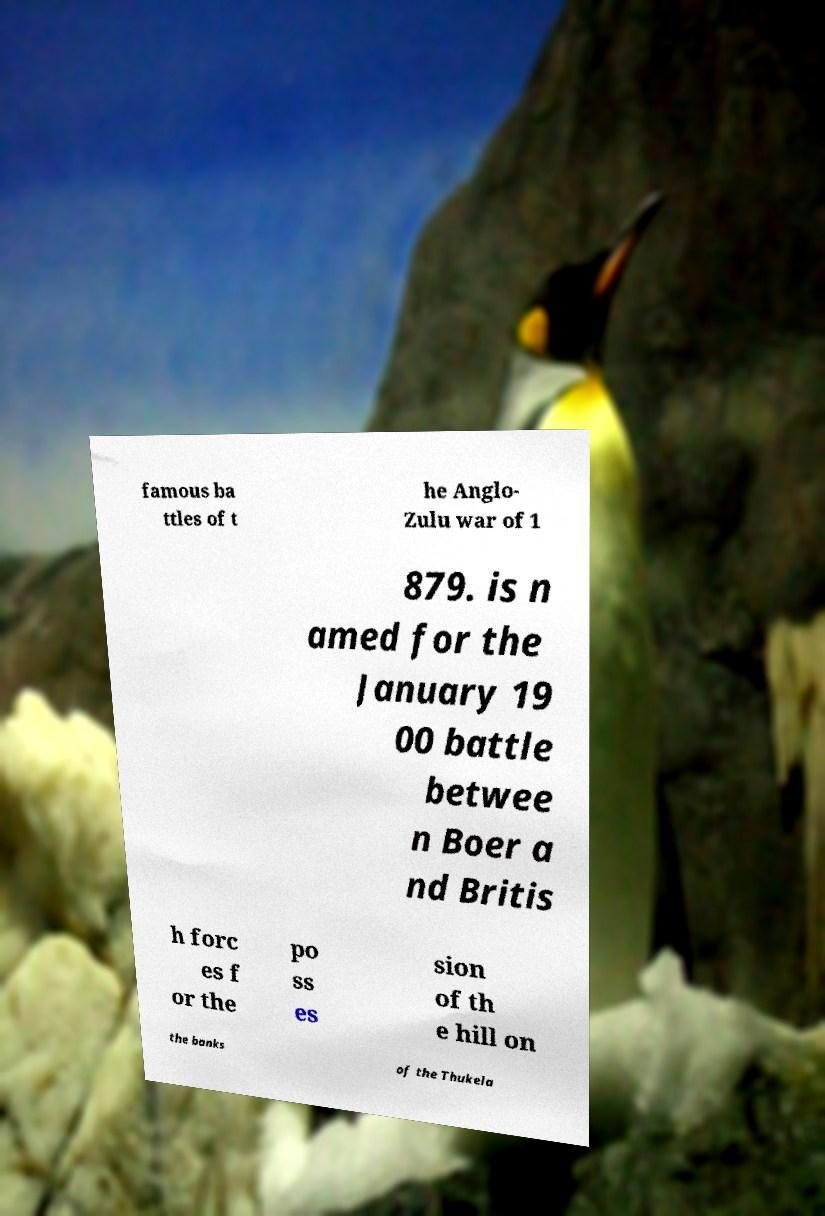There's text embedded in this image that I need extracted. Can you transcribe it verbatim? famous ba ttles of t he Anglo- Zulu war of 1 879. is n amed for the January 19 00 battle betwee n Boer a nd Britis h forc es f or the po ss es sion of th e hill on the banks of the Thukela 